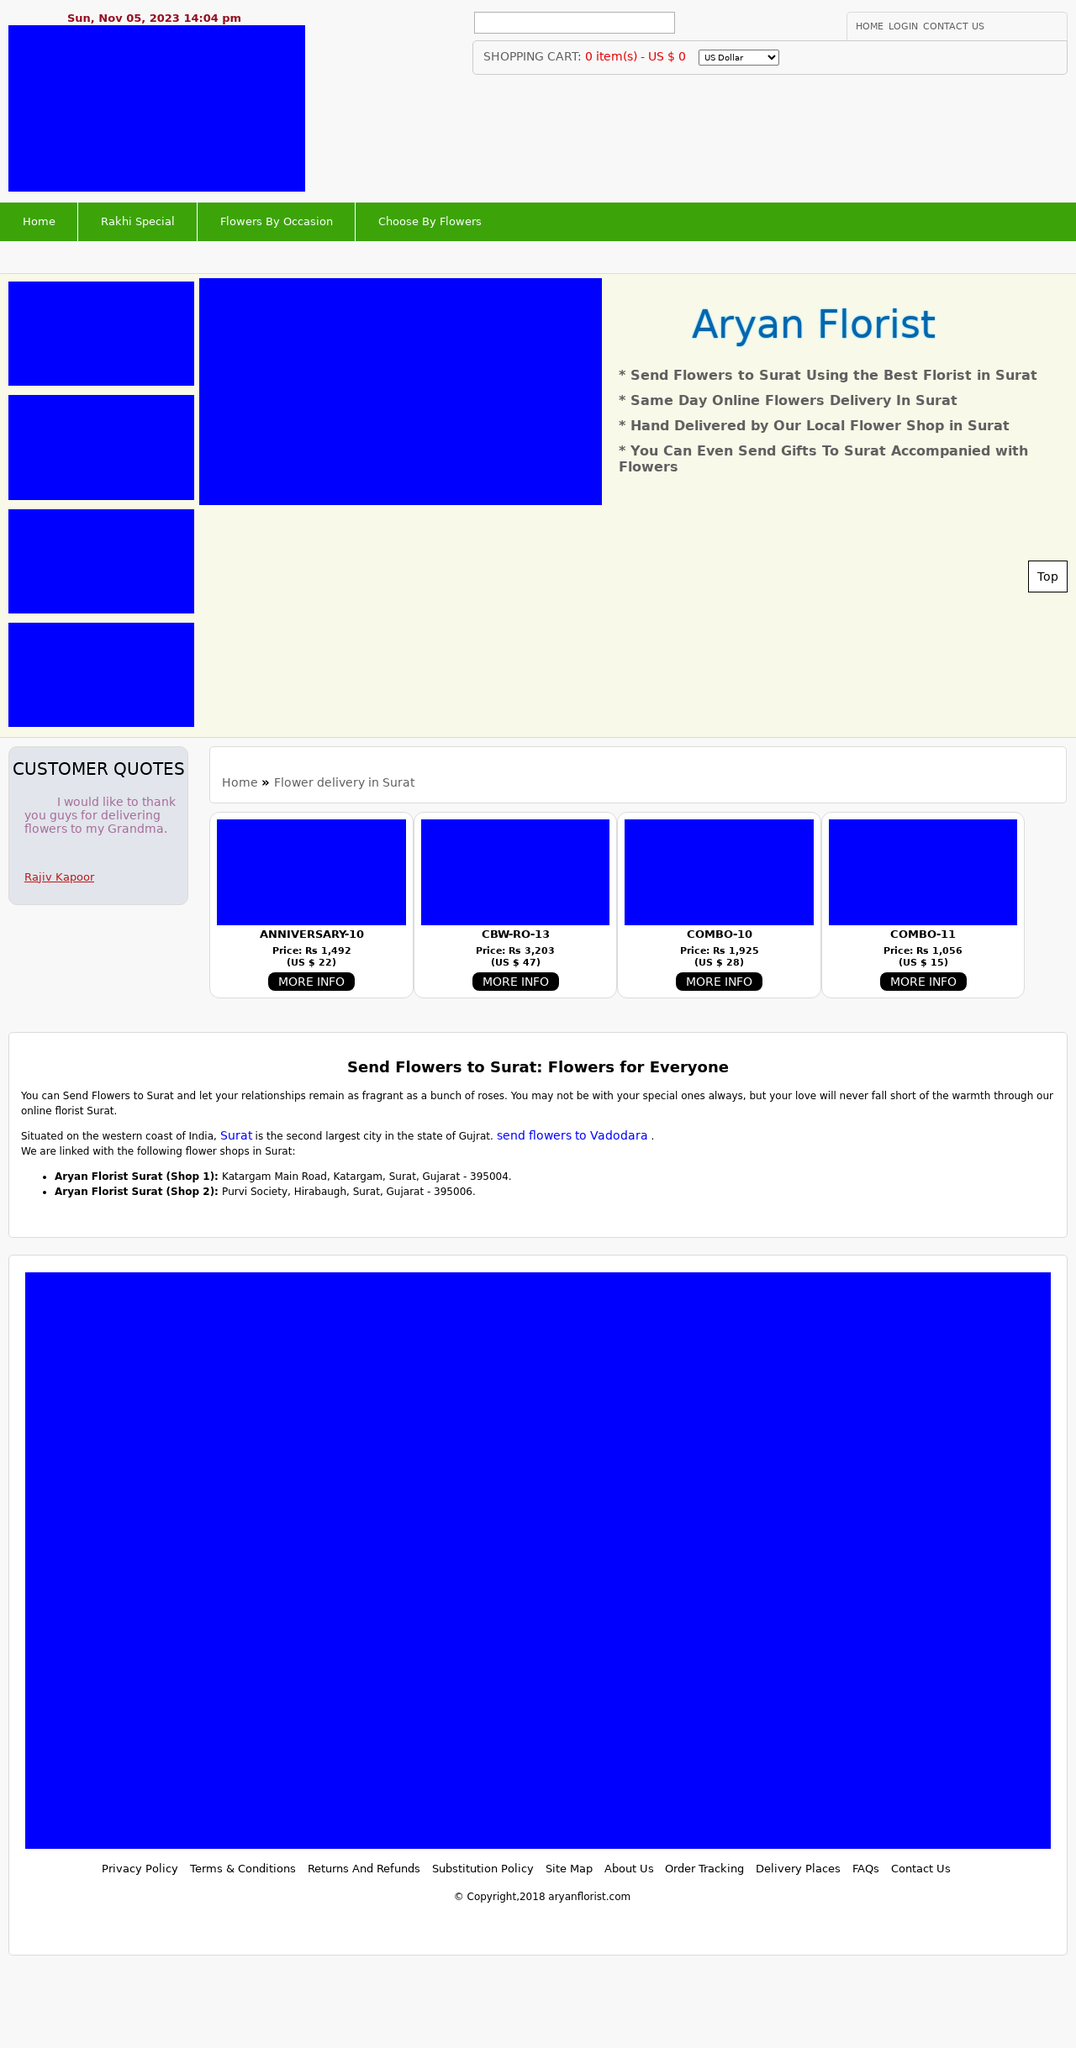Can you describe the significance of the 'Customer Quotes' section in the website shown in this image? The 'Customer Quotes' section in the website shown adds credibility and trust to the business by displaying positive reviews from past customers. Such testimonials can significantly influence potential customers' decisions by providing real-world endorsements of your services or products. It's a direct form of social proof that helps website visitors feel more secure in their decision to engage with your company. 